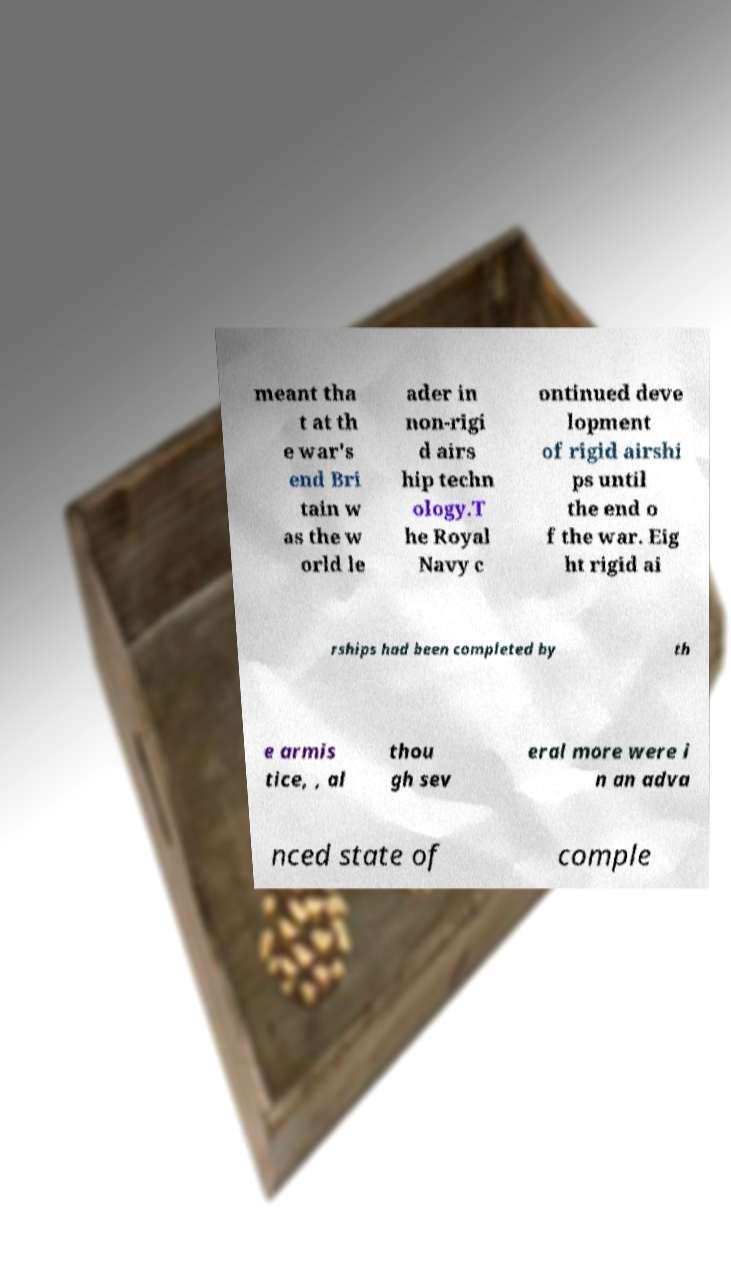What messages or text are displayed in this image? I need them in a readable, typed format. meant tha t at th e war's end Bri tain w as the w orld le ader in non-rigi d airs hip techn ology.T he Royal Navy c ontinued deve lopment of rigid airshi ps until the end o f the war. Eig ht rigid ai rships had been completed by th e armis tice, , al thou gh sev eral more were i n an adva nced state of comple 